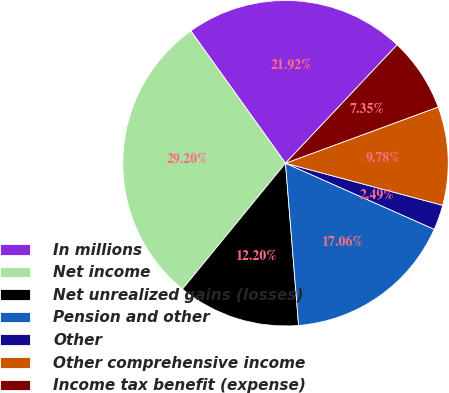Convert chart. <chart><loc_0><loc_0><loc_500><loc_500><pie_chart><fcel>In millions<fcel>Net income<fcel>Net unrealized gains (losses)<fcel>Pension and other<fcel>Other<fcel>Other comprehensive income<fcel>Income tax benefit (expense)<nl><fcel>21.92%<fcel>29.2%<fcel>12.2%<fcel>17.06%<fcel>2.49%<fcel>9.78%<fcel>7.35%<nl></chart> 